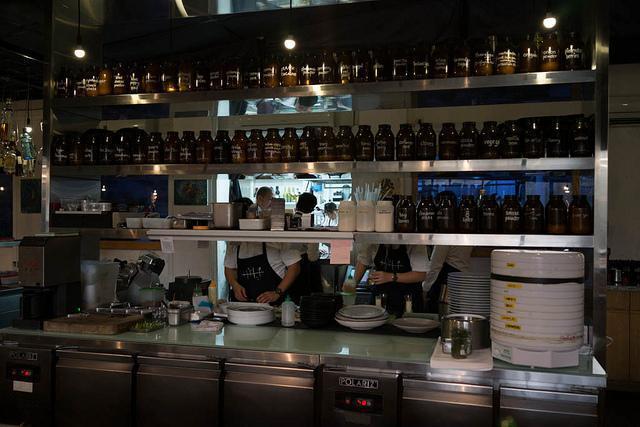How many people are visible?
Give a very brief answer. 2. 